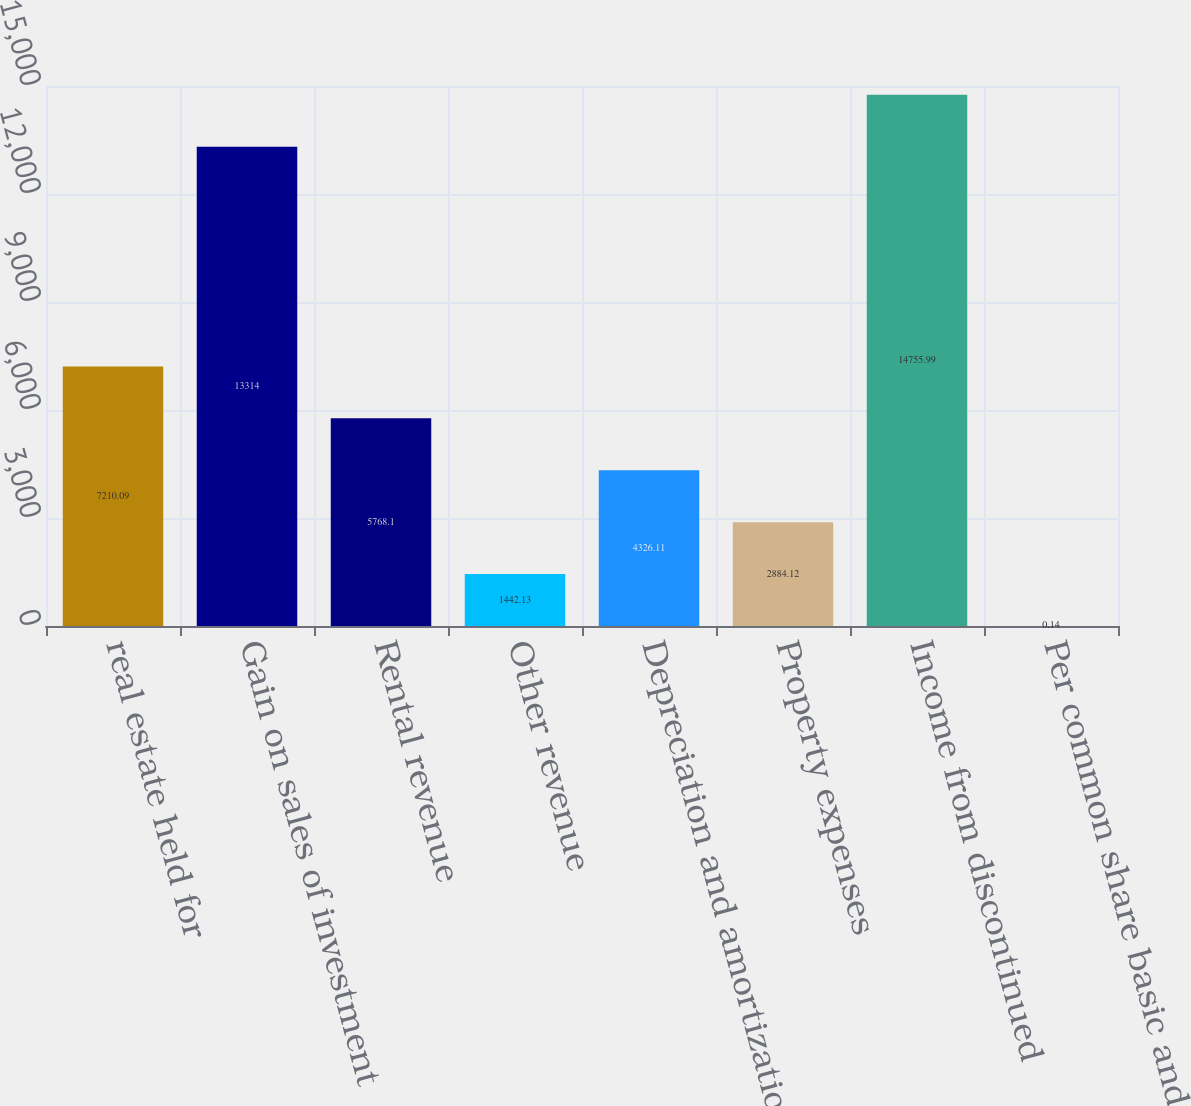Convert chart to OTSL. <chart><loc_0><loc_0><loc_500><loc_500><bar_chart><fcel>real estate held for<fcel>Gain on sales of investment<fcel>Rental revenue<fcel>Other revenue<fcel>Depreciation and amortization<fcel>Property expenses<fcel>Income from discontinued<fcel>Per common share basic and<nl><fcel>7210.09<fcel>13314<fcel>5768.1<fcel>1442.13<fcel>4326.11<fcel>2884.12<fcel>14756<fcel>0.14<nl></chart> 